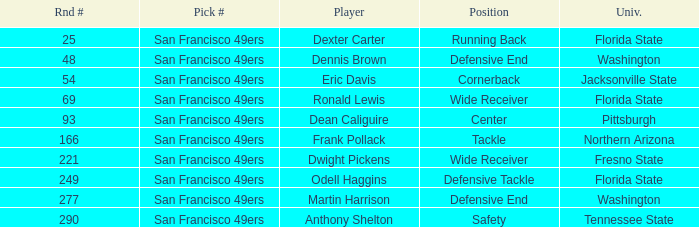What is the College with a Player that is dean caliguire? Pittsburgh. Write the full table. {'header': ['Rnd #', 'Pick #', 'Player', 'Position', 'Univ.'], 'rows': [['25', 'San Francisco 49ers', 'Dexter Carter', 'Running Back', 'Florida State'], ['48', 'San Francisco 49ers', 'Dennis Brown', 'Defensive End', 'Washington'], ['54', 'San Francisco 49ers', 'Eric Davis', 'Cornerback', 'Jacksonville State'], ['69', 'San Francisco 49ers', 'Ronald Lewis', 'Wide Receiver', 'Florida State'], ['93', 'San Francisco 49ers', 'Dean Caliguire', 'Center', 'Pittsburgh'], ['166', 'San Francisco 49ers', 'Frank Pollack', 'Tackle', 'Northern Arizona'], ['221', 'San Francisco 49ers', 'Dwight Pickens', 'Wide Receiver', 'Fresno State'], ['249', 'San Francisco 49ers', 'Odell Haggins', 'Defensive Tackle', 'Florida State'], ['277', 'San Francisco 49ers', 'Martin Harrison', 'Defensive End', 'Washington'], ['290', 'San Francisco 49ers', 'Anthony Shelton', 'Safety', 'Tennessee State']]} 